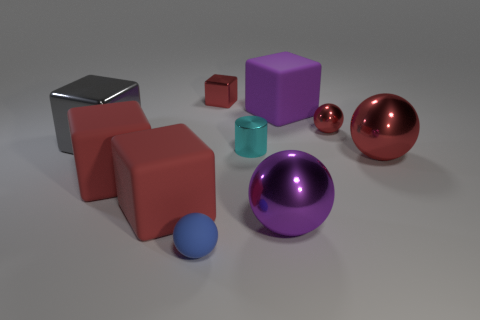What number of tiny balls have the same color as the small cube?
Offer a terse response. 1. There is a metal cube that is in front of the big matte block that is right of the tiny red thing that is behind the purple rubber cube; what is its color?
Your answer should be very brief. Gray. What color is the big sphere on the left side of the big red metallic sphere?
Ensure brevity in your answer.  Purple. What is the color of the matte sphere that is the same size as the metallic cylinder?
Keep it short and to the point. Blue. Does the red metal block have the same size as the purple ball?
Offer a very short reply. No. There is a tiny red block; how many big shiny things are to the left of it?
Ensure brevity in your answer.  1. How many objects are cubes behind the large gray shiny cube or big things?
Your answer should be very brief. 7. Are there more big red metal spheres behind the small cyan metal cylinder than tiny red metal blocks in front of the purple shiny sphere?
Your response must be concise. No. What is the size of the other sphere that is the same color as the tiny metallic sphere?
Provide a succinct answer. Large. Is the size of the gray metal block the same as the red metal ball that is behind the small cyan cylinder?
Your answer should be compact. No. 